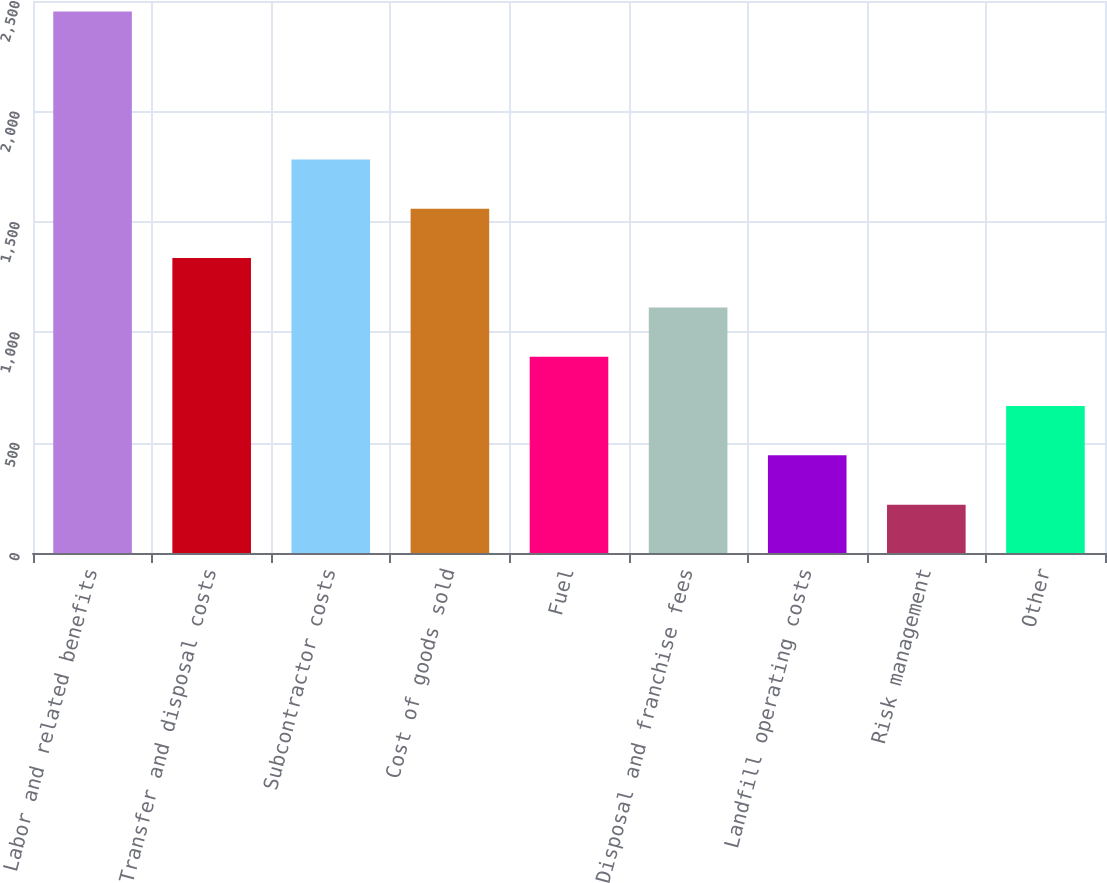Convert chart. <chart><loc_0><loc_0><loc_500><loc_500><bar_chart><fcel>Labor and related benefits<fcel>Transfer and disposal costs<fcel>Subcontractor costs<fcel>Cost of goods sold<fcel>Fuel<fcel>Disposal and franchise fees<fcel>Landfill operating costs<fcel>Risk management<fcel>Other<nl><fcel>2452<fcel>1335.5<fcel>1782.1<fcel>1558.8<fcel>888.9<fcel>1112.2<fcel>442.3<fcel>219<fcel>665.6<nl></chart> 